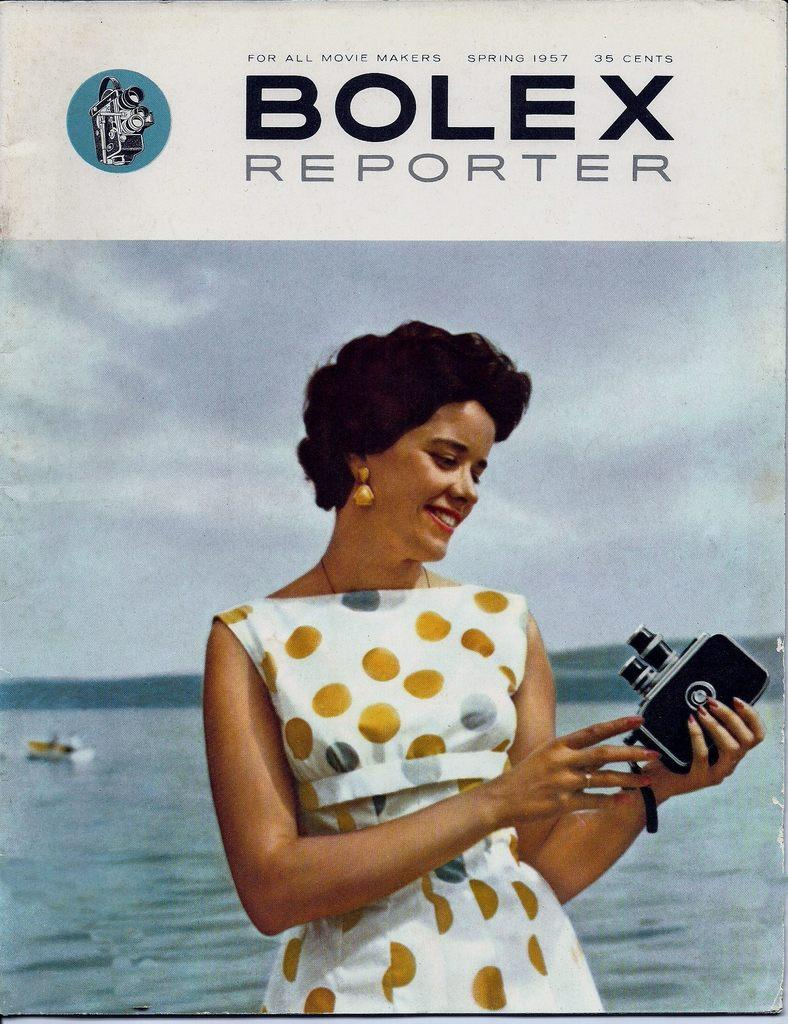What is the main object in the image? There is a poster in the image. What can be seen on the poster? There are pictures and text in the image. What type of meat is hanging from the string in the image? There is no meat or string present in the image. 